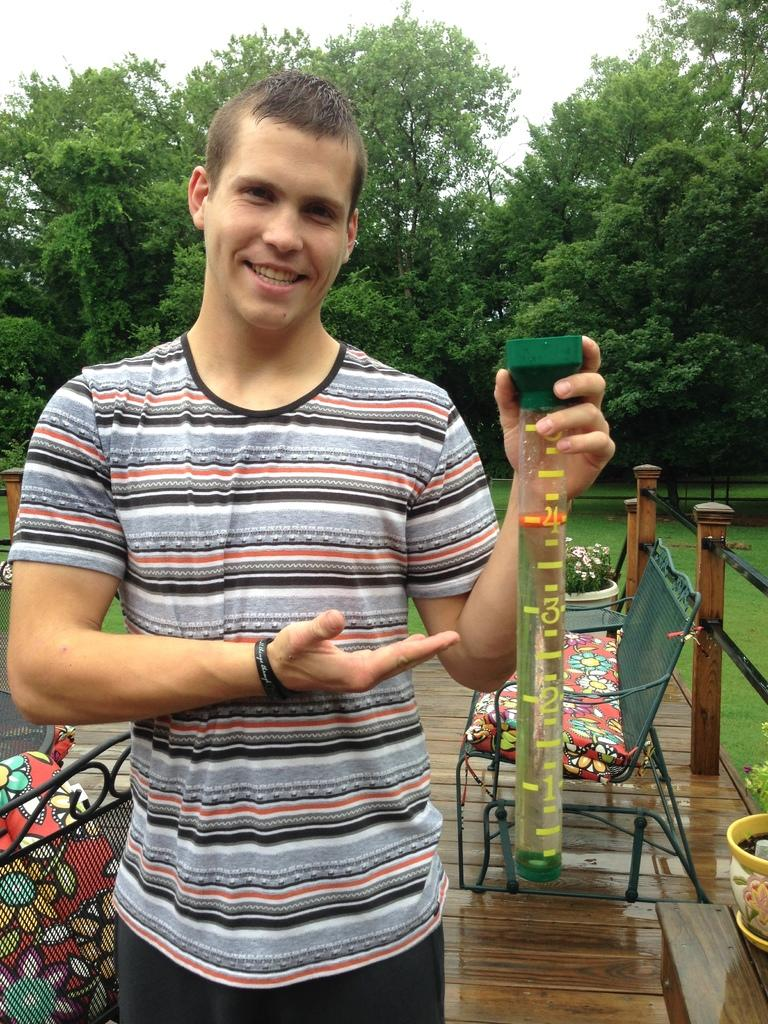What is the man in the image doing? The man is standing and smiling in the image. What is the man holding in the image? The man is holding an item in the image. What type of furniture can be seen in the image? There are chairs in the image. What type of vegetation is present in the image? There are plants in pots and trees in the image. What type of ground surface is visible in the image? There is grass visible in the image. What can be seen in the background of the image? The sky is visible in the background of the image. What language is the kitten speaking in the image? There is no kitten present in the image, so it is not possible to determine what language it might be speaking. 